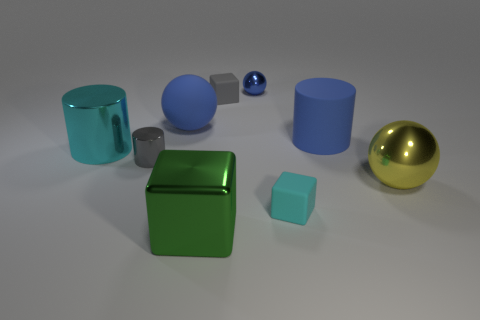There is a small ball; are there any shiny cylinders on the right side of it?
Offer a terse response. No. The rubber thing that is the same shape as the big yellow metallic thing is what size?
Your answer should be compact. Large. Is there anything else that has the same size as the cyan metal object?
Make the answer very short. Yes. Is the shape of the gray matte object the same as the small cyan rubber thing?
Offer a terse response. Yes. There is a blue ball that is right of the large ball that is behind the gray cylinder; how big is it?
Ensure brevity in your answer.  Small. What color is the big rubber object that is the same shape as the blue metal thing?
Ensure brevity in your answer.  Blue. What number of rubber things have the same color as the tiny cylinder?
Keep it short and to the point. 1. The shiny block is what size?
Make the answer very short. Large. Is the yellow sphere the same size as the blue shiny object?
Ensure brevity in your answer.  No. What color is the large shiny thing that is both on the left side of the large yellow shiny sphere and behind the large green metallic object?
Make the answer very short. Cyan. 